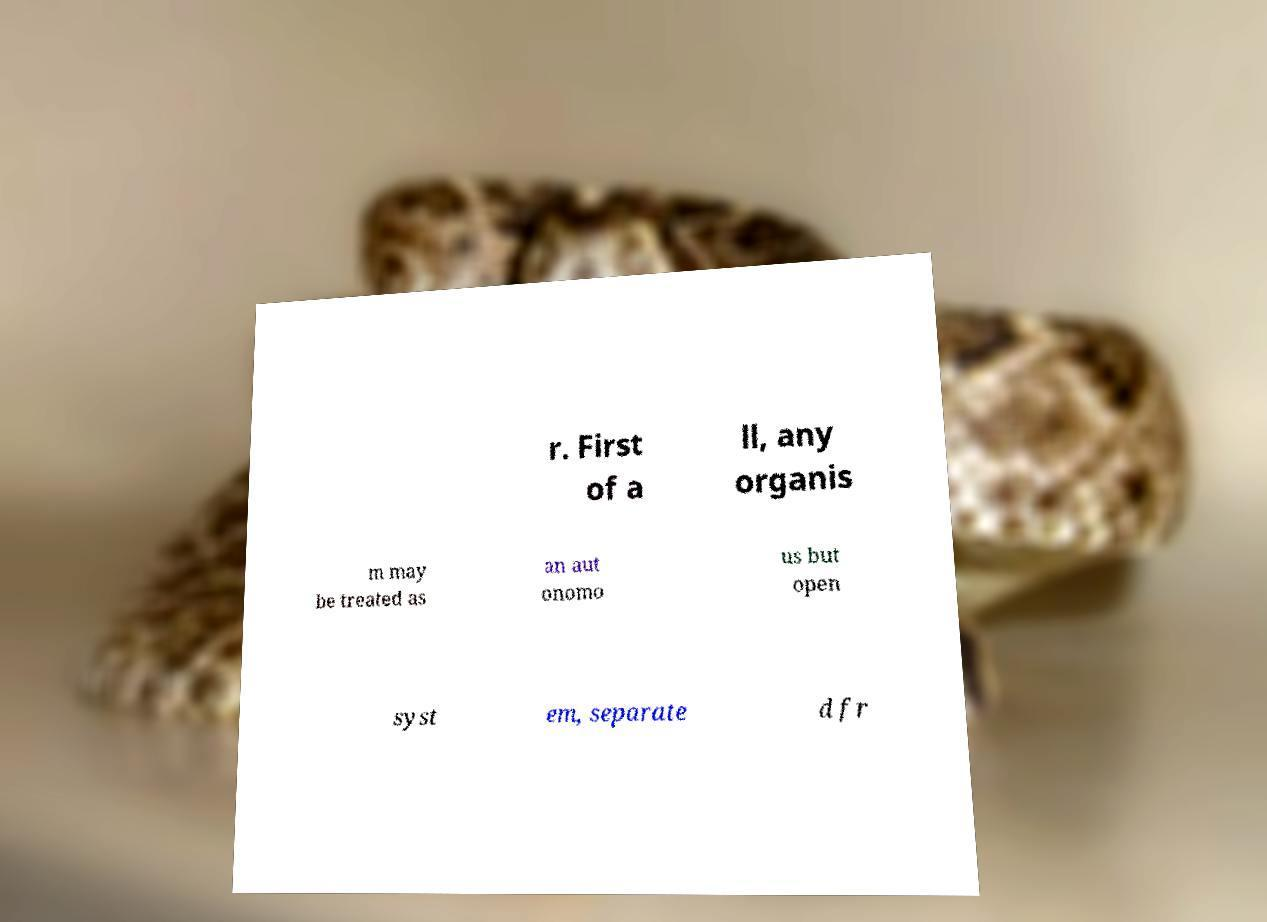For documentation purposes, I need the text within this image transcribed. Could you provide that? r. First of a ll, any organis m may be treated as an aut onomo us but open syst em, separate d fr 